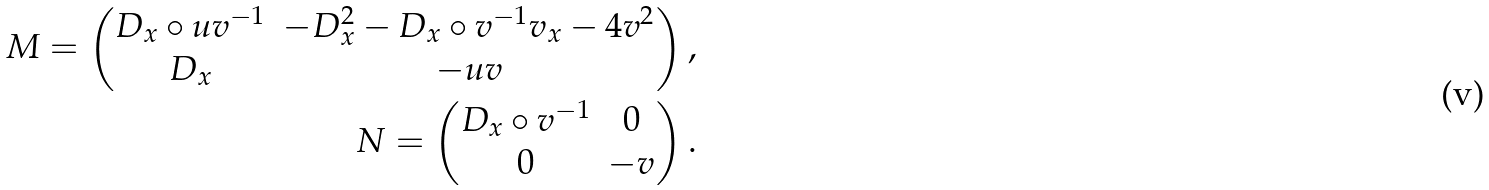Convert formula to latex. <formula><loc_0><loc_0><loc_500><loc_500>M = \begin{pmatrix} D _ { x } \circ u v ^ { - 1 } & - D _ { x } ^ { 2 } - D _ { x } \circ v ^ { - 1 } v _ { x } - 4 v ^ { 2 } \\ D _ { x } & - u v \end{pmatrix} , \\ N = \begin{pmatrix} D _ { x } \circ v ^ { - 1 } & 0 \\ 0 & - v \end{pmatrix} .</formula> 